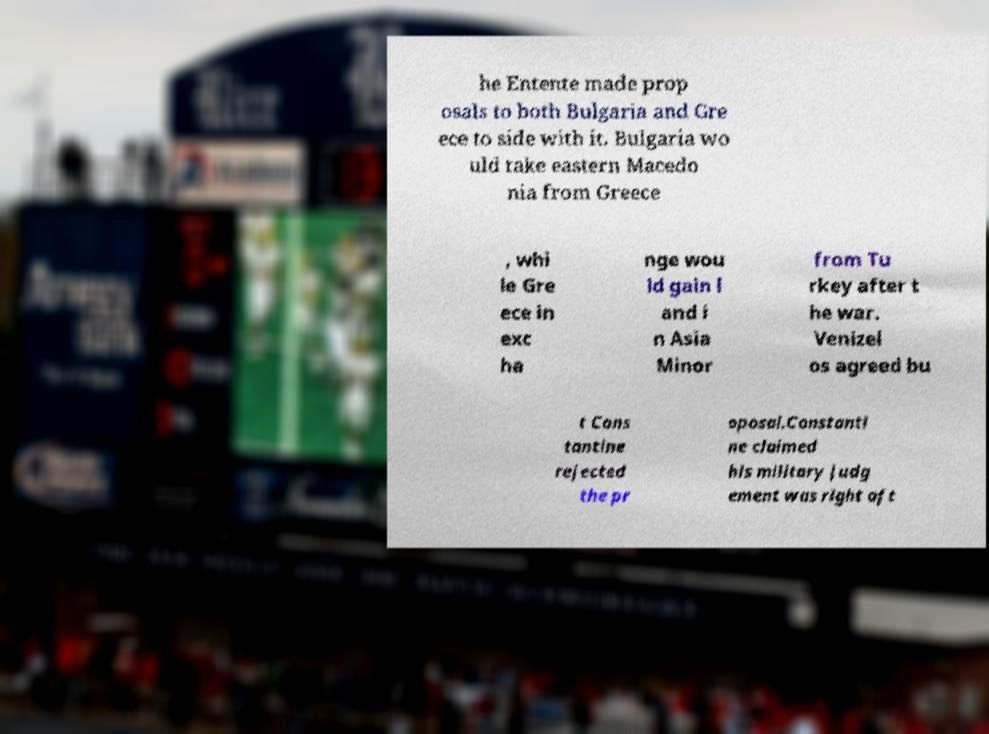Could you extract and type out the text from this image? he Entente made prop osals to both Bulgaria and Gre ece to side with it. Bulgaria wo uld take eastern Macedo nia from Greece , whi le Gre ece in exc ha nge wou ld gain l and i n Asia Minor from Tu rkey after t he war. Venizel os agreed bu t Cons tantine rejected the pr oposal.Constanti ne claimed his military judg ement was right aft 